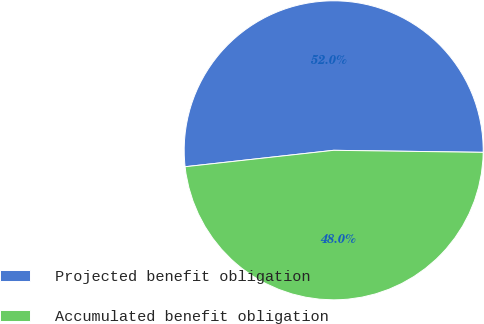Convert chart to OTSL. <chart><loc_0><loc_0><loc_500><loc_500><pie_chart><fcel>Projected benefit obligation<fcel>Accumulated benefit obligation<nl><fcel>51.97%<fcel>48.03%<nl></chart> 